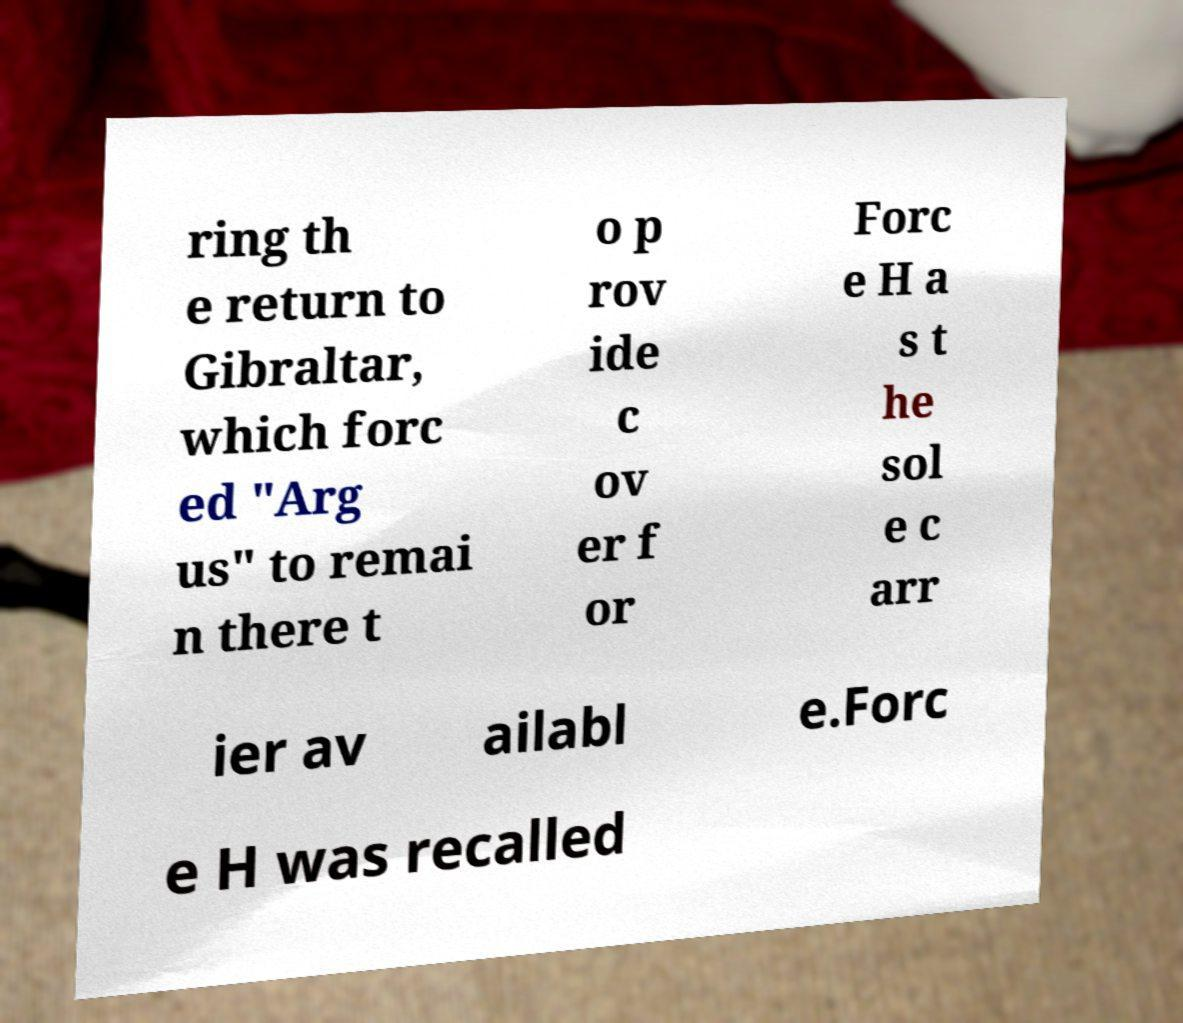Can you accurately transcribe the text from the provided image for me? ring th e return to Gibraltar, which forc ed "Arg us" to remai n there t o p rov ide c ov er f or Forc e H a s t he sol e c arr ier av ailabl e.Forc e H was recalled 